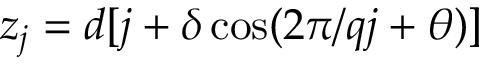<formula> <loc_0><loc_0><loc_500><loc_500>z _ { j } = d [ j + \delta \cos ( 2 \pi / q j + \theta ) ]</formula> 